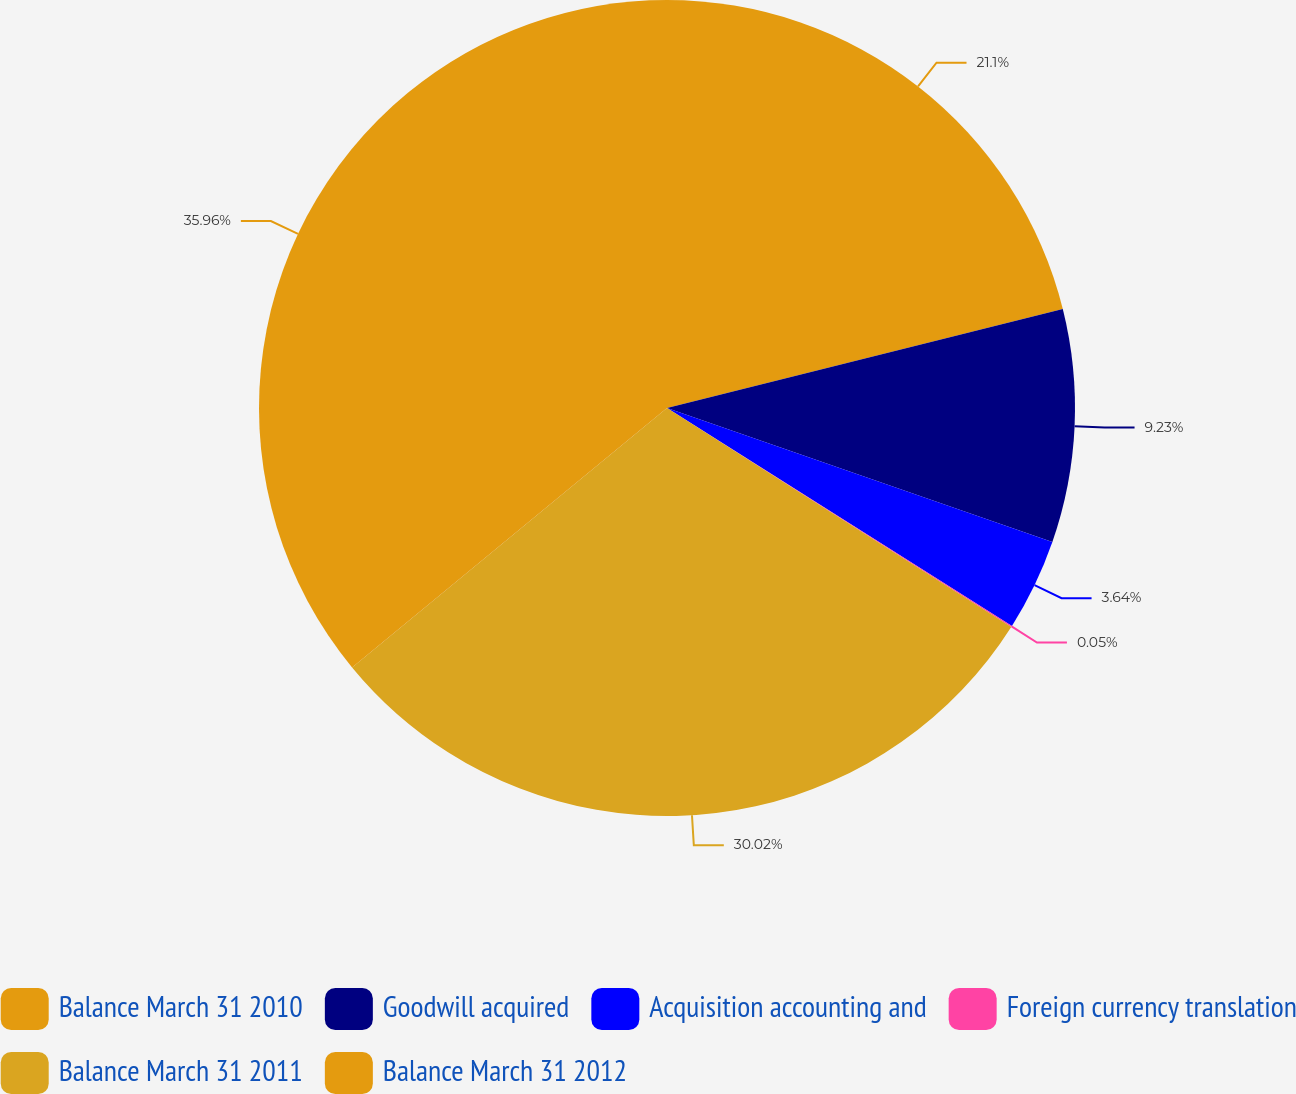Convert chart. <chart><loc_0><loc_0><loc_500><loc_500><pie_chart><fcel>Balance March 31 2010<fcel>Goodwill acquired<fcel>Acquisition accounting and<fcel>Foreign currency translation<fcel>Balance March 31 2011<fcel>Balance March 31 2012<nl><fcel>21.1%<fcel>9.23%<fcel>3.64%<fcel>0.05%<fcel>30.02%<fcel>35.97%<nl></chart> 